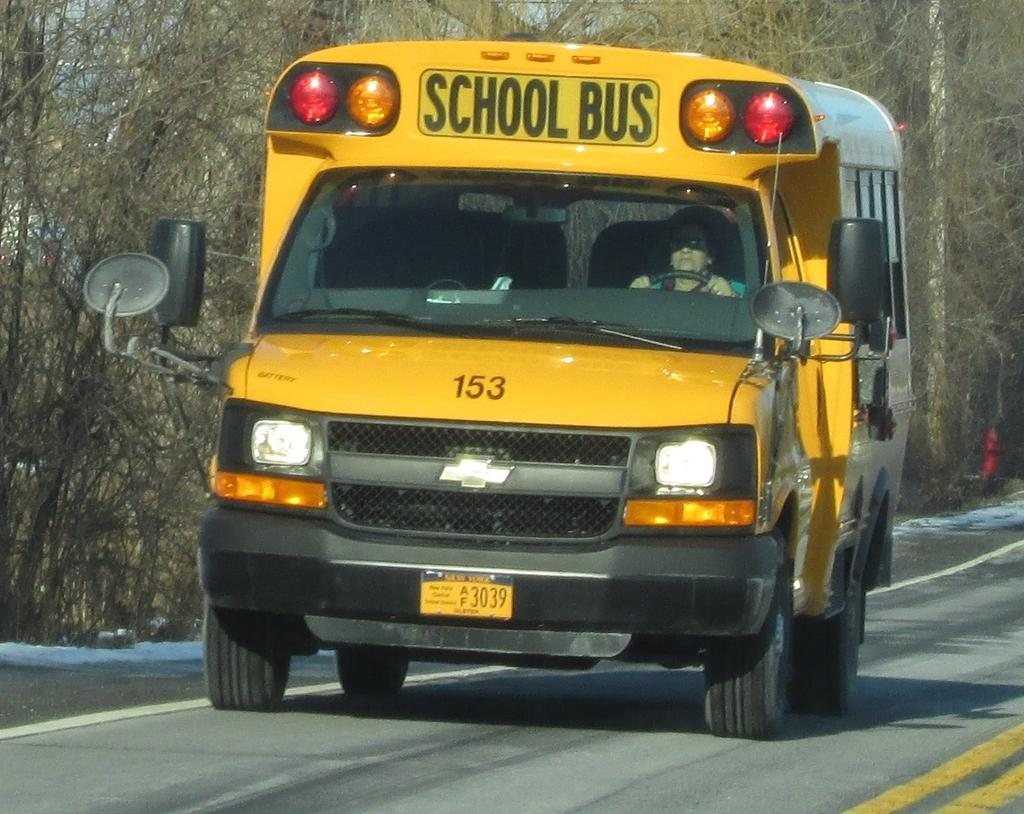What is the main subject of the image? There is a bus in the image. Where is the bus located? The bus is on the road. Can you describe the interior of the bus? There is a person seated in the bus. What can be seen in the background of the image? There are trees and snow visible in the background of the image. What type of orange is being used as a fact-checking tool in the image? There is no orange present in the image, nor is there any mention of fact-checking. 